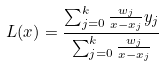<formula> <loc_0><loc_0><loc_500><loc_500>L ( x ) = { \frac { \sum _ { j = 0 } ^ { k } { \frac { w _ { j } } { x - x _ { j } } } y _ { j } } { \sum _ { j = 0 } ^ { k } { \frac { w _ { j } } { x - x _ { j } } } } }</formula> 